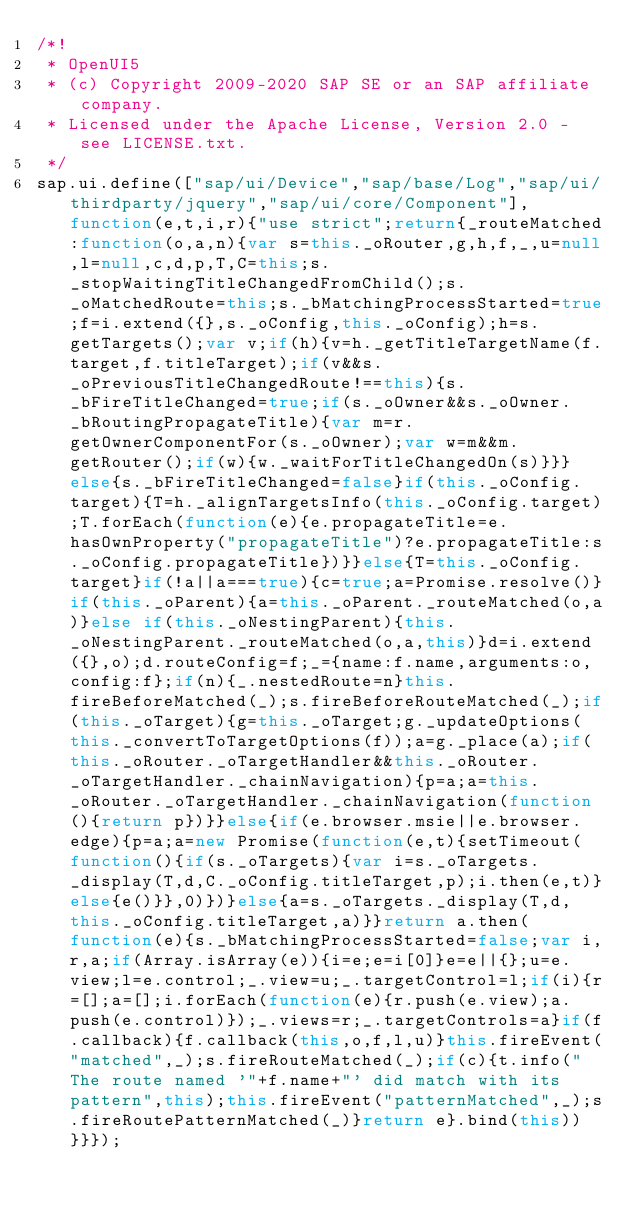<code> <loc_0><loc_0><loc_500><loc_500><_JavaScript_>/*!
 * OpenUI5
 * (c) Copyright 2009-2020 SAP SE or an SAP affiliate company.
 * Licensed under the Apache License, Version 2.0 - see LICENSE.txt.
 */
sap.ui.define(["sap/ui/Device","sap/base/Log","sap/ui/thirdparty/jquery","sap/ui/core/Component"],function(e,t,i,r){"use strict";return{_routeMatched:function(o,a,n){var s=this._oRouter,g,h,f,_,u=null,l=null,c,d,p,T,C=this;s._stopWaitingTitleChangedFromChild();s._oMatchedRoute=this;s._bMatchingProcessStarted=true;f=i.extend({},s._oConfig,this._oConfig);h=s.getTargets();var v;if(h){v=h._getTitleTargetName(f.target,f.titleTarget);if(v&&s._oPreviousTitleChangedRoute!==this){s._bFireTitleChanged=true;if(s._oOwner&&s._oOwner._bRoutingPropagateTitle){var m=r.getOwnerComponentFor(s._oOwner);var w=m&&m.getRouter();if(w){w._waitForTitleChangedOn(s)}}}else{s._bFireTitleChanged=false}if(this._oConfig.target){T=h._alignTargetsInfo(this._oConfig.target);T.forEach(function(e){e.propagateTitle=e.hasOwnProperty("propagateTitle")?e.propagateTitle:s._oConfig.propagateTitle})}}else{T=this._oConfig.target}if(!a||a===true){c=true;a=Promise.resolve()}if(this._oParent){a=this._oParent._routeMatched(o,a)}else if(this._oNestingParent){this._oNestingParent._routeMatched(o,a,this)}d=i.extend({},o);d.routeConfig=f;_={name:f.name,arguments:o,config:f};if(n){_.nestedRoute=n}this.fireBeforeMatched(_);s.fireBeforeRouteMatched(_);if(this._oTarget){g=this._oTarget;g._updateOptions(this._convertToTargetOptions(f));a=g._place(a);if(this._oRouter._oTargetHandler&&this._oRouter._oTargetHandler._chainNavigation){p=a;a=this._oRouter._oTargetHandler._chainNavigation(function(){return p})}}else{if(e.browser.msie||e.browser.edge){p=a;a=new Promise(function(e,t){setTimeout(function(){if(s._oTargets){var i=s._oTargets._display(T,d,C._oConfig.titleTarget,p);i.then(e,t)}else{e()}},0)})}else{a=s._oTargets._display(T,d,this._oConfig.titleTarget,a)}}return a.then(function(e){s._bMatchingProcessStarted=false;var i,r,a;if(Array.isArray(e)){i=e;e=i[0]}e=e||{};u=e.view;l=e.control;_.view=u;_.targetControl=l;if(i){r=[];a=[];i.forEach(function(e){r.push(e.view);a.push(e.control)});_.views=r;_.targetControls=a}if(f.callback){f.callback(this,o,f,l,u)}this.fireEvent("matched",_);s.fireRouteMatched(_);if(c){t.info("The route named '"+f.name+"' did match with its pattern",this);this.fireEvent("patternMatched",_);s.fireRoutePatternMatched(_)}return e}.bind(this))}}});</code> 